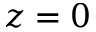Convert formula to latex. <formula><loc_0><loc_0><loc_500><loc_500>z = 0</formula> 